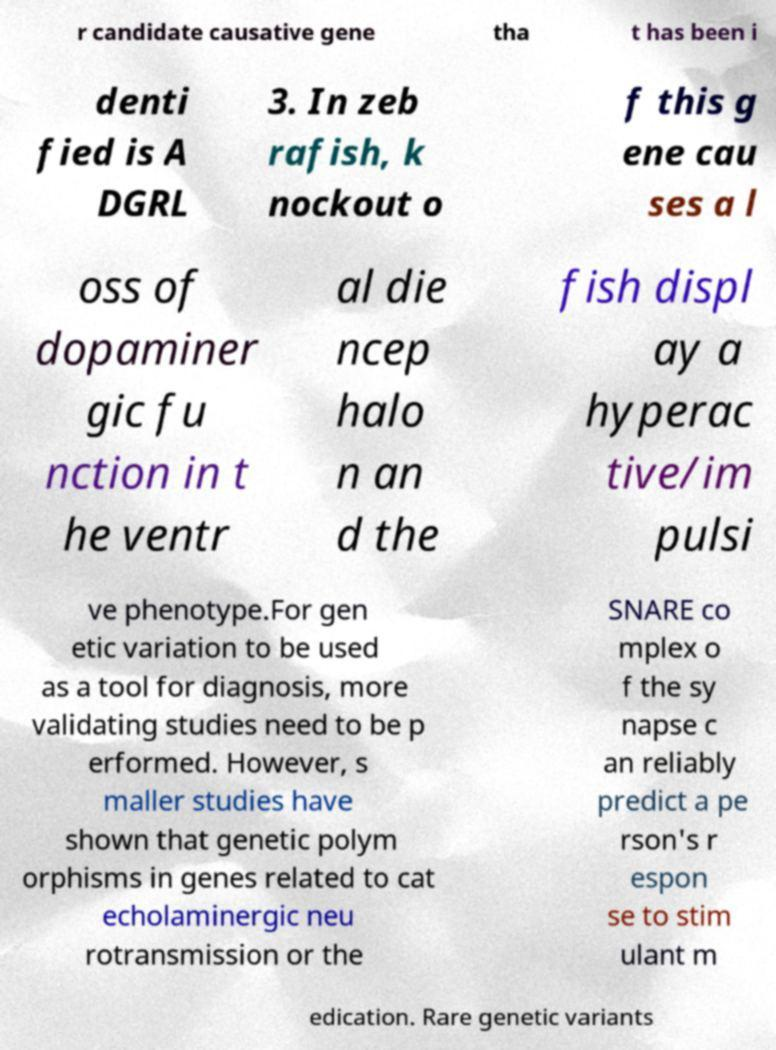Could you assist in decoding the text presented in this image and type it out clearly? r candidate causative gene tha t has been i denti fied is A DGRL 3. In zeb rafish, k nockout o f this g ene cau ses a l oss of dopaminer gic fu nction in t he ventr al die ncep halo n an d the fish displ ay a hyperac tive/im pulsi ve phenotype.For gen etic variation to be used as a tool for diagnosis, more validating studies need to be p erformed. However, s maller studies have shown that genetic polym orphisms in genes related to cat echolaminergic neu rotransmission or the SNARE co mplex o f the sy napse c an reliably predict a pe rson's r espon se to stim ulant m edication. Rare genetic variants 